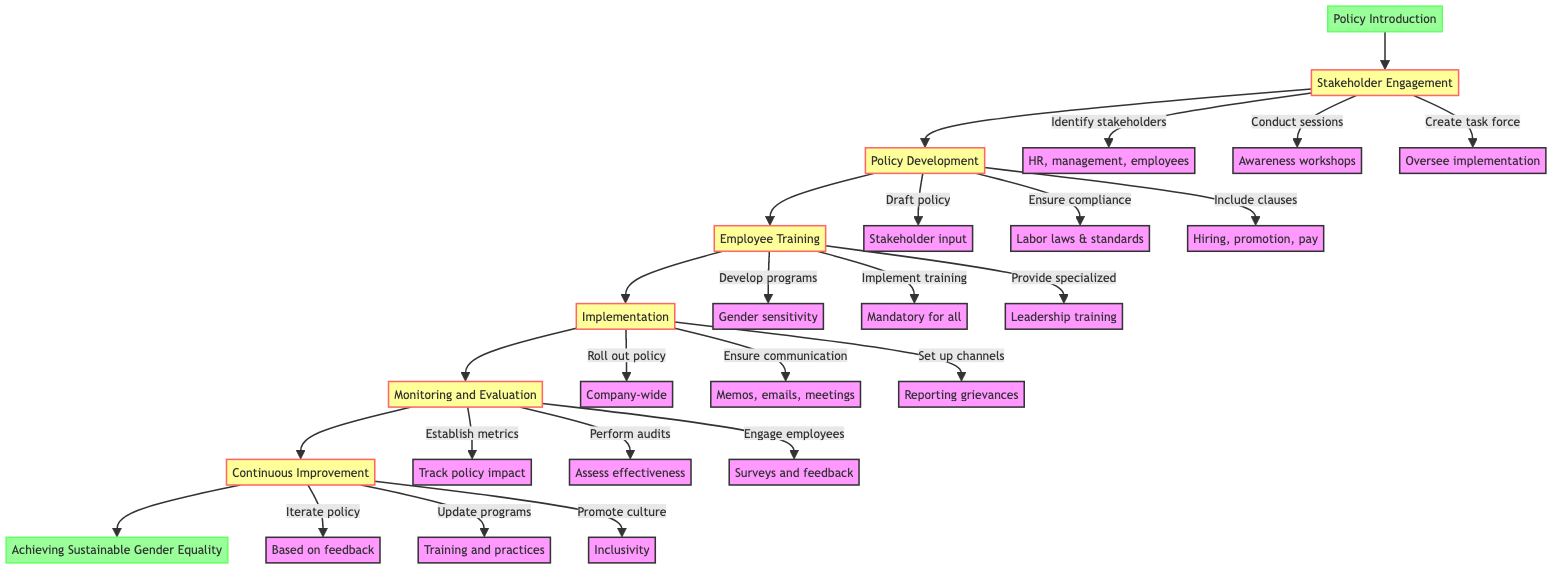What is the starting point of the flow chart? The flow chart begins with the node labeled "Policy Introduction," which is indicated as the first step in the process of implementing gender equality policy.
Answer: Policy Introduction How many stages are there in the diagram? The diagram outlines a total of six stages, each represented by a node connected in sequence from "Stakeholder Engagement" to "Continuous Improvement."
Answer: 6 What follows after "Policy Development"? The flow chart shows that "Employee Training" directly follows the "Policy Development" stage, indicating the next step in the implementation process.
Answer: Employee Training Which party is responsible for creating a task force? The responsibility of creating a task force falls under the "Stakeholder Engagement" stage, as shown in the diagram where it is listed as one of the actions taken.
Answer: Stakeholders What is the final stage of the process? The last stage in the flow of the diagram is "Achieving Sustainable Gender Equality," which marks the endpoint of the overall implementation process.
Answer: Achieving Sustainable Gender Equality Which stage includes the rollout of the policy? The implementation of the gender equality policy takes place during the "Implementation" stage, as stated in the flow chart.
Answer: Implementation What is included in the policy development stage? The "Policy Development" stage includes drafting the policy, ensuring compliance with labor laws and international standards, and including specific clauses for hiring, promotion, and pay practices.
Answer: Drafting policy, ensuring compliance, including clauses How do the stages interrelate in the flow chart? The stages in the flow chart are sequentially ordered, meaning each stage leads to the next as part of a continuous process, starting from policy introduction and leading to sustaining gender equality.
Answer: Sequentially Which component measures the policy's impact? The "Monitoring and Evaluation" stage is responsible for establishing metrics to track the impact of the gender equality policy on aspects like gender ratio and pay equity.
Answer: Monitoring and Evaluation 